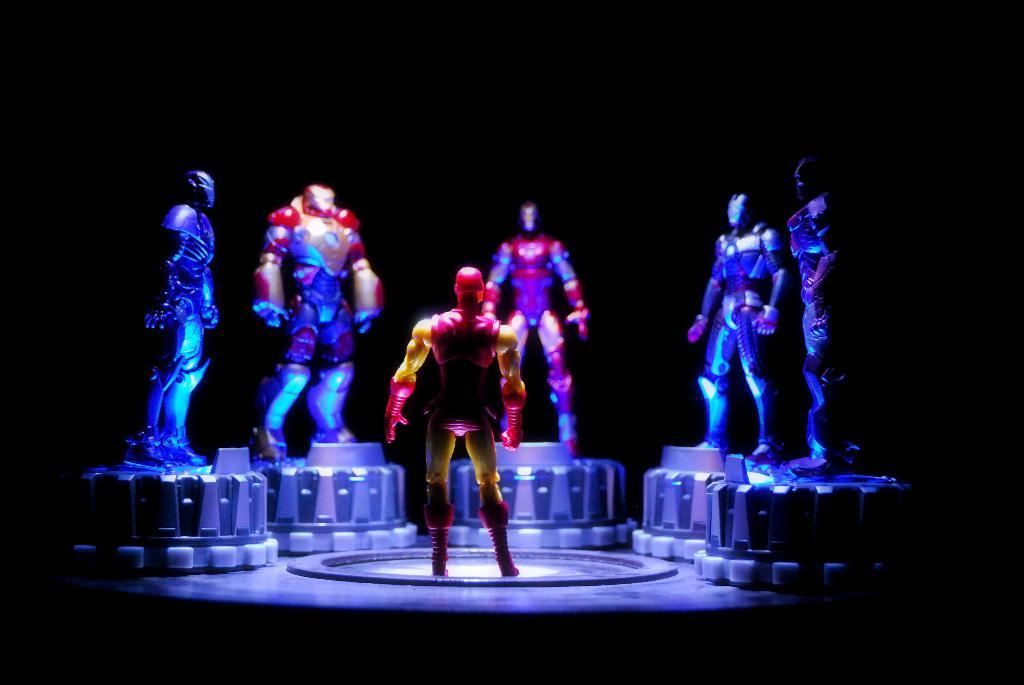What objects can be seen in the image? There are toys in the image. What can be observed about the background of the image? The background of the image is dark. What type of pest can be seen crawling on the toys in the image? There is no pest visible in the image; it only features toys and a dark background. 